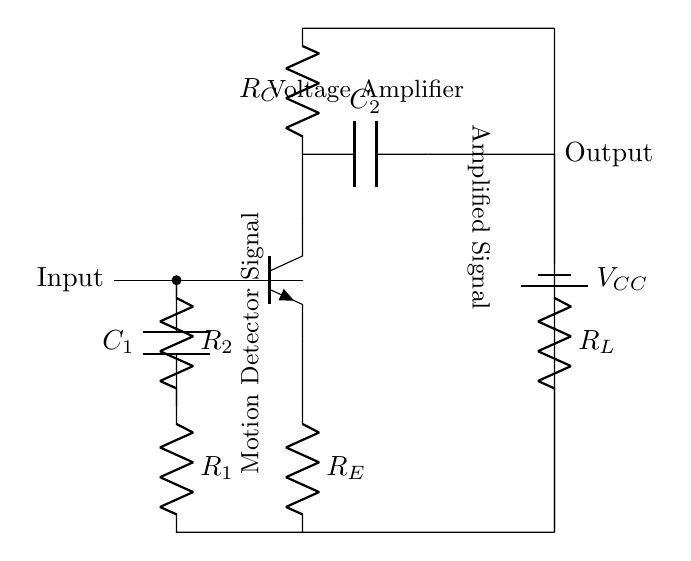What is the type of transistor used in the circuit? The circuit shows an npn transistor as indicated by the label next to the transistor component.
Answer: npn What is the role of capacitor C1? Capacitor C1 is used to couple the motion detector signal into the transistor's input, allowing AC signals to pass while blocking DC components.
Answer: Coupling What is the purpose of resistors R1 and R2? Resistors R1 and R2 are biasing resistors that help to set the operating point of the transistor, ensuring it operates in the active region.
Answer: Biasing What component amplifies the input signal? The amplified signal is produced by the transistor, which increases the strength of the input signal from the motion detector.
Answer: Transistor What is the output of the circuit labeled as? The output of the circuit is labeled as "Output," indicating where the amplified signal can be taken from.
Answer: Output How does the circuit achieve voltage amplification? Voltage amplification is achieved via the active component (the npn transistor) that increases the voltage level of the input signal based on the biasing resistors and load resistor in the circuit.
Answer: Transistor What is the voltage supply in this circuit? The voltage supply is labeled as VCC, which is typically a positive voltage supplied to the circuit for proper operation of the transistor.
Answer: VCC 